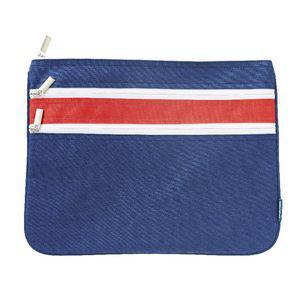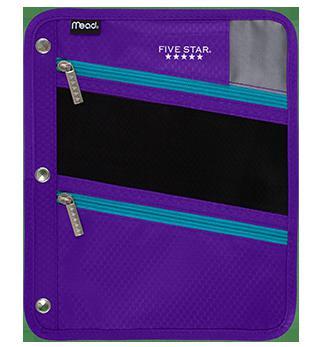The first image is the image on the left, the second image is the image on the right. Given the left and right images, does the statement "An image shows a closed, flat case with red and blue elements and multiple zippers across the front." hold true? Answer yes or no. Yes. The first image is the image on the left, the second image is the image on the right. For the images shown, is this caption "There is a thick pencil case and a thin one, both closed." true? Answer yes or no. No. 